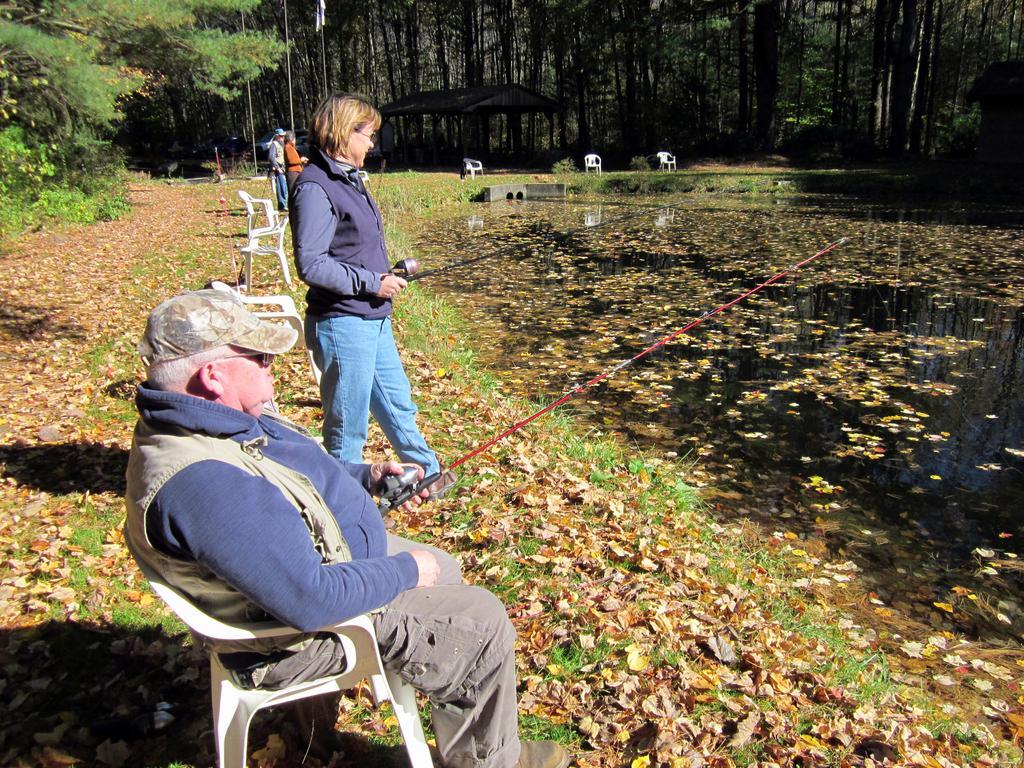Please provide a concise description of this image. In this picture we can see there are three persons standing on the grass and a man is sitting on a chair. There are two persons holding fishing rods. On the right side of the image, there is water. Behind the people there are chairs, shed and trees. 